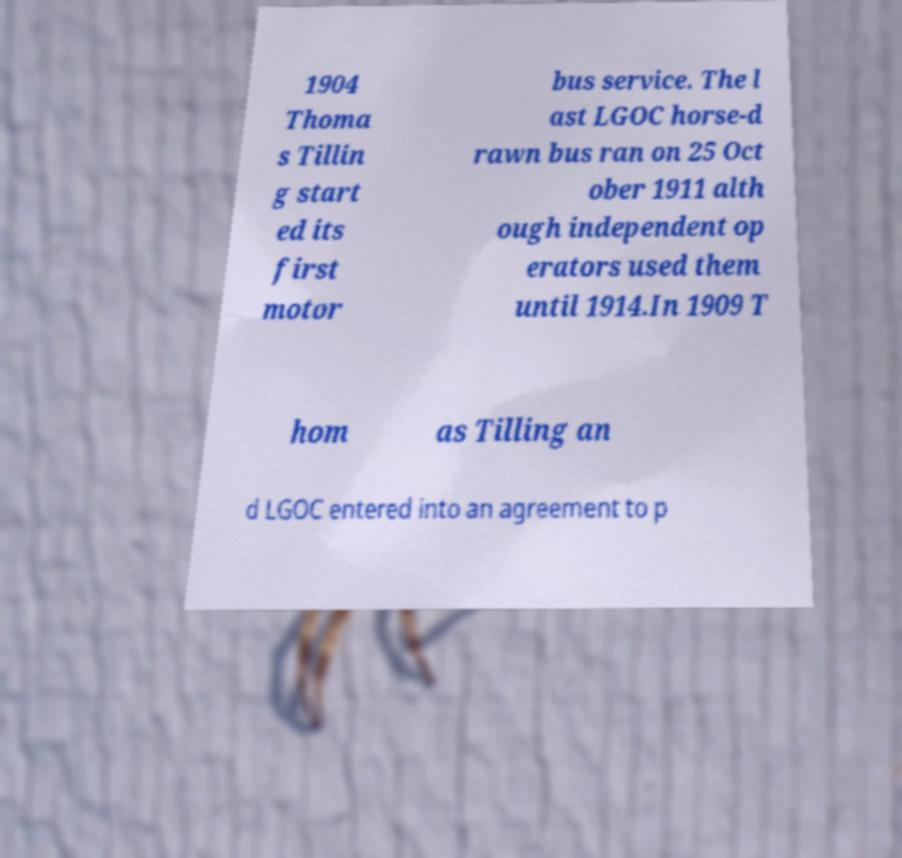Can you read and provide the text displayed in the image?This photo seems to have some interesting text. Can you extract and type it out for me? 1904 Thoma s Tillin g start ed its first motor bus service. The l ast LGOC horse-d rawn bus ran on 25 Oct ober 1911 alth ough independent op erators used them until 1914.In 1909 T hom as Tilling an d LGOC entered into an agreement to p 